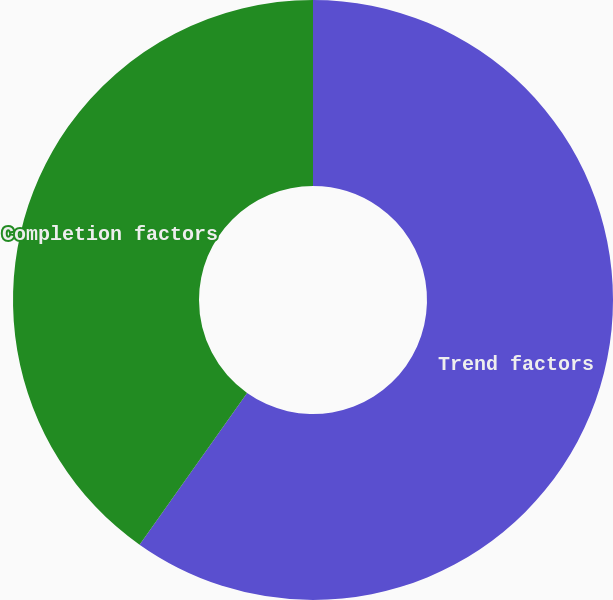Convert chart. <chart><loc_0><loc_0><loc_500><loc_500><pie_chart><fcel>Trend factors<fcel>Completion factors<nl><fcel>59.81%<fcel>40.19%<nl></chart> 